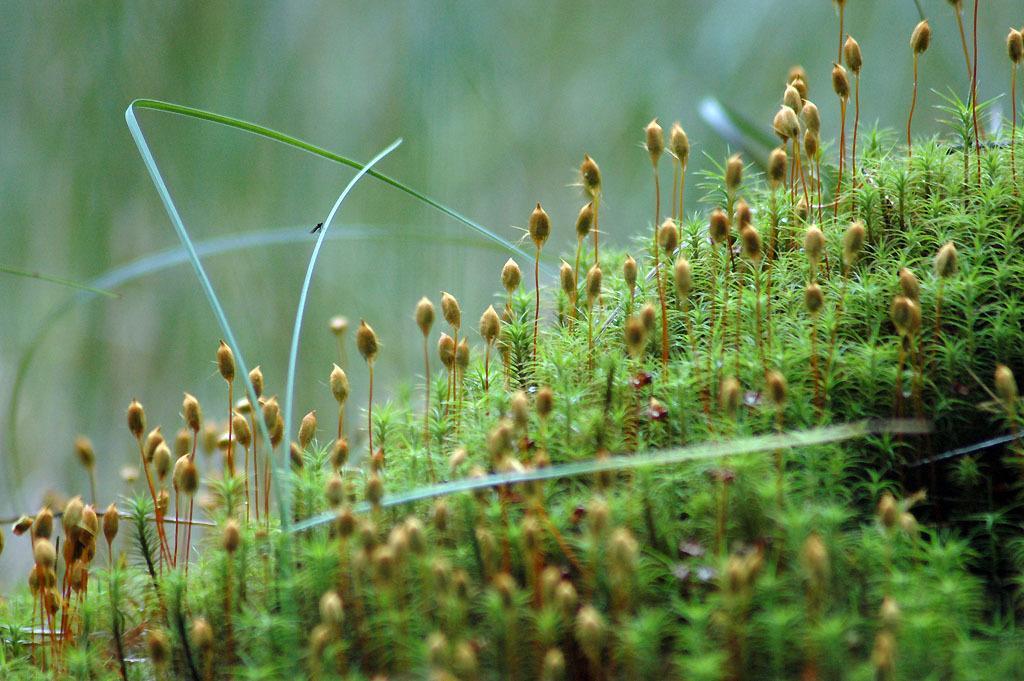Describe this image in one or two sentences. In the image I can see plants and an insect on a plant. The background of the image is blurred. 